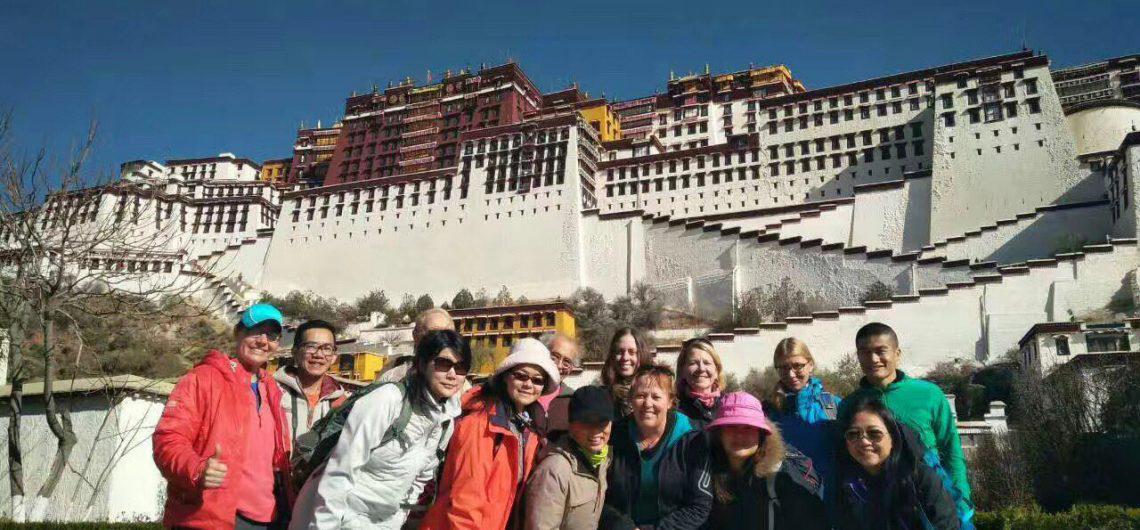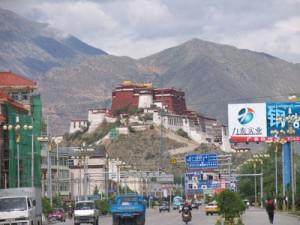The first image is the image on the left, the second image is the image on the right. Given the left and right images, does the statement "In at least one image there is a group standing in front of a three story white stari wall that is below four rows of window." hold true? Answer yes or no. Yes. The first image is the image on the left, the second image is the image on the right. Evaluate the accuracy of this statement regarding the images: "In exactly one image a group of people are posing in front of a structure.". Is it true? Answer yes or no. Yes. 